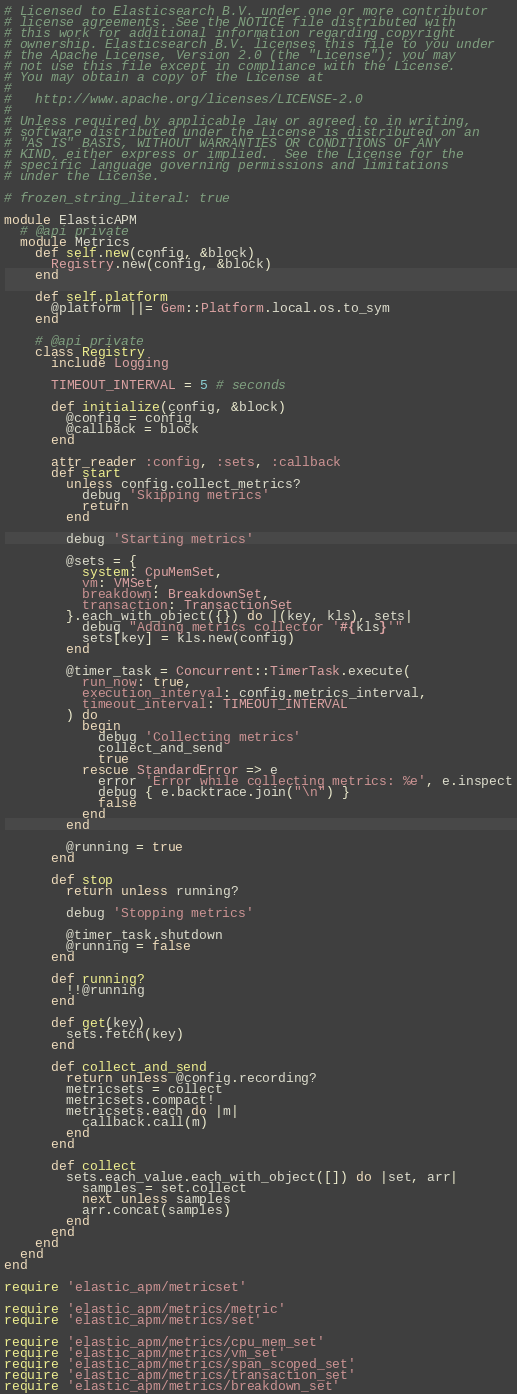Convert code to text. <code><loc_0><loc_0><loc_500><loc_500><_Ruby_># Licensed to Elasticsearch B.V. under one or more contributor
# license agreements. See the NOTICE file distributed with
# this work for additional information regarding copyright
# ownership. Elasticsearch B.V. licenses this file to you under
# the Apache License, Version 2.0 (the "License"); you may
# not use this file except in compliance with the License.
# You may obtain a copy of the License at
#
#   http://www.apache.org/licenses/LICENSE-2.0
#
# Unless required by applicable law or agreed to in writing,
# software distributed under the License is distributed on an
# "AS IS" BASIS, WITHOUT WARRANTIES OR CONDITIONS OF ANY
# KIND, either express or implied.  See the License for the
# specific language governing permissions and limitations
# under the License.

# frozen_string_literal: true

module ElasticAPM
  # @api private
  module Metrics
    def self.new(config, &block)
      Registry.new(config, &block)
    end

    def self.platform
      @platform ||= Gem::Platform.local.os.to_sym
    end

    # @api private
    class Registry
      include Logging

      TIMEOUT_INTERVAL = 5 # seconds

      def initialize(config, &block)
        @config = config
        @callback = block
      end

      attr_reader :config, :sets, :callback
      def start
        unless config.collect_metrics?
          debug 'Skipping metrics'
          return
        end

        debug 'Starting metrics'

        @sets = {
          system: CpuMemSet,
          vm: VMSet,
          breakdown: BreakdownSet,
          transaction: TransactionSet
        }.each_with_object({}) do |(key, kls), sets|
          debug "Adding metrics collector '#{kls}'"
          sets[key] = kls.new(config)
        end

        @timer_task = Concurrent::TimerTask.execute(
          run_now: true,
          execution_interval: config.metrics_interval,
          timeout_interval: TIMEOUT_INTERVAL
        ) do
          begin
            debug 'Collecting metrics'
            collect_and_send
            true
          rescue StandardError => e
            error 'Error while collecting metrics: %e', e.inspect
            debug { e.backtrace.join("\n") }
            false
          end
        end

        @running = true
      end

      def stop
        return unless running?

        debug 'Stopping metrics'

        @timer_task.shutdown
        @running = false
      end

      def running?
        !!@running
      end

      def get(key)
        sets.fetch(key)
      end

      def collect_and_send
        return unless @config.recording?
        metricsets = collect
        metricsets.compact!
        metricsets.each do |m|
          callback.call(m)
        end
      end

      def collect
        sets.each_value.each_with_object([]) do |set, arr|
          samples = set.collect
          next unless samples
          arr.concat(samples)
        end
      end
    end
  end
end

require 'elastic_apm/metricset'

require 'elastic_apm/metrics/metric'
require 'elastic_apm/metrics/set'

require 'elastic_apm/metrics/cpu_mem_set'
require 'elastic_apm/metrics/vm_set'
require 'elastic_apm/metrics/span_scoped_set'
require 'elastic_apm/metrics/transaction_set'
require 'elastic_apm/metrics/breakdown_set'
</code> 